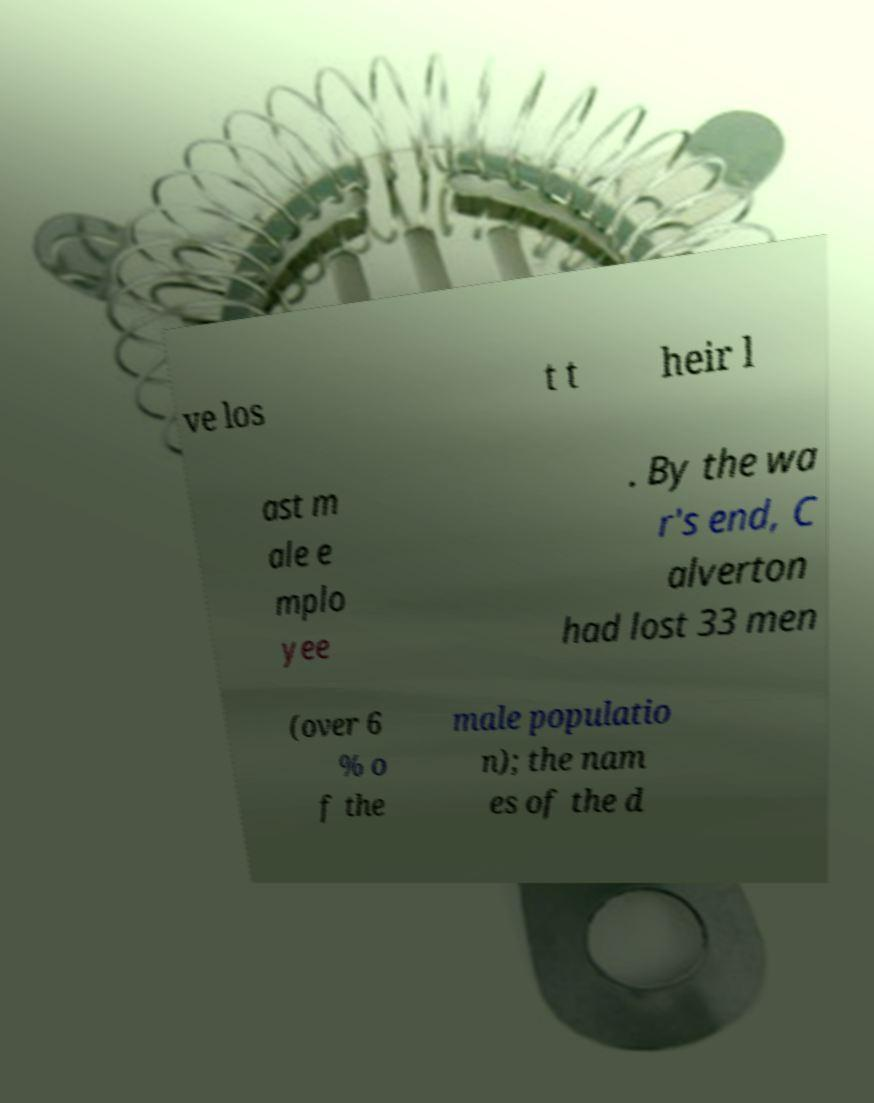I need the written content from this picture converted into text. Can you do that? ve los t t heir l ast m ale e mplo yee . By the wa r's end, C alverton had lost 33 men (over 6 % o f the male populatio n); the nam es of the d 